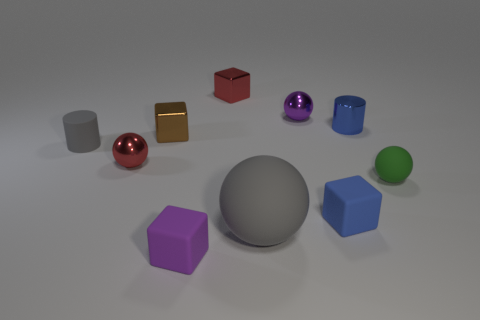Are there any brown shiny blocks right of the gray rubber ball? no 